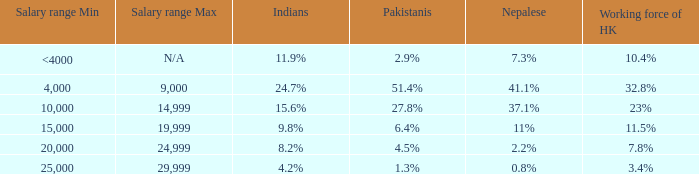If the Indians are 8.2%, what is the salary range? 20,000-24,999. Help me parse the entirety of this table. {'header': ['Salary range Min', 'Salary range Max', 'Indians', 'Pakistanis', 'Nepalese', 'Working force of HK'], 'rows': [['<4000', 'N/A', '11.9%', '2.9%', '7.3%', '10.4%'], ['4,000', '9,000', '24.7%', '51.4%', '41.1%', '32.8%'], ['10,000', '14,999', '15.6%', '27.8%', '37.1%', '23%'], ['15,000', '19,999', '9.8%', '6.4%', '11%', '11.5%'], ['20,000', '24,999', '8.2%', '4.5%', '2.2%', '7.8%'], ['25,000', '29,999', '4.2%', '1.3%', '0.8%', '3.4%']]} 